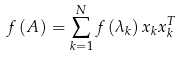<formula> <loc_0><loc_0><loc_500><loc_500>f \left ( A \right ) = \sum _ { k = 1 } ^ { N } f \left ( \lambda _ { k } \right ) x _ { k } x _ { k } ^ { T }</formula> 